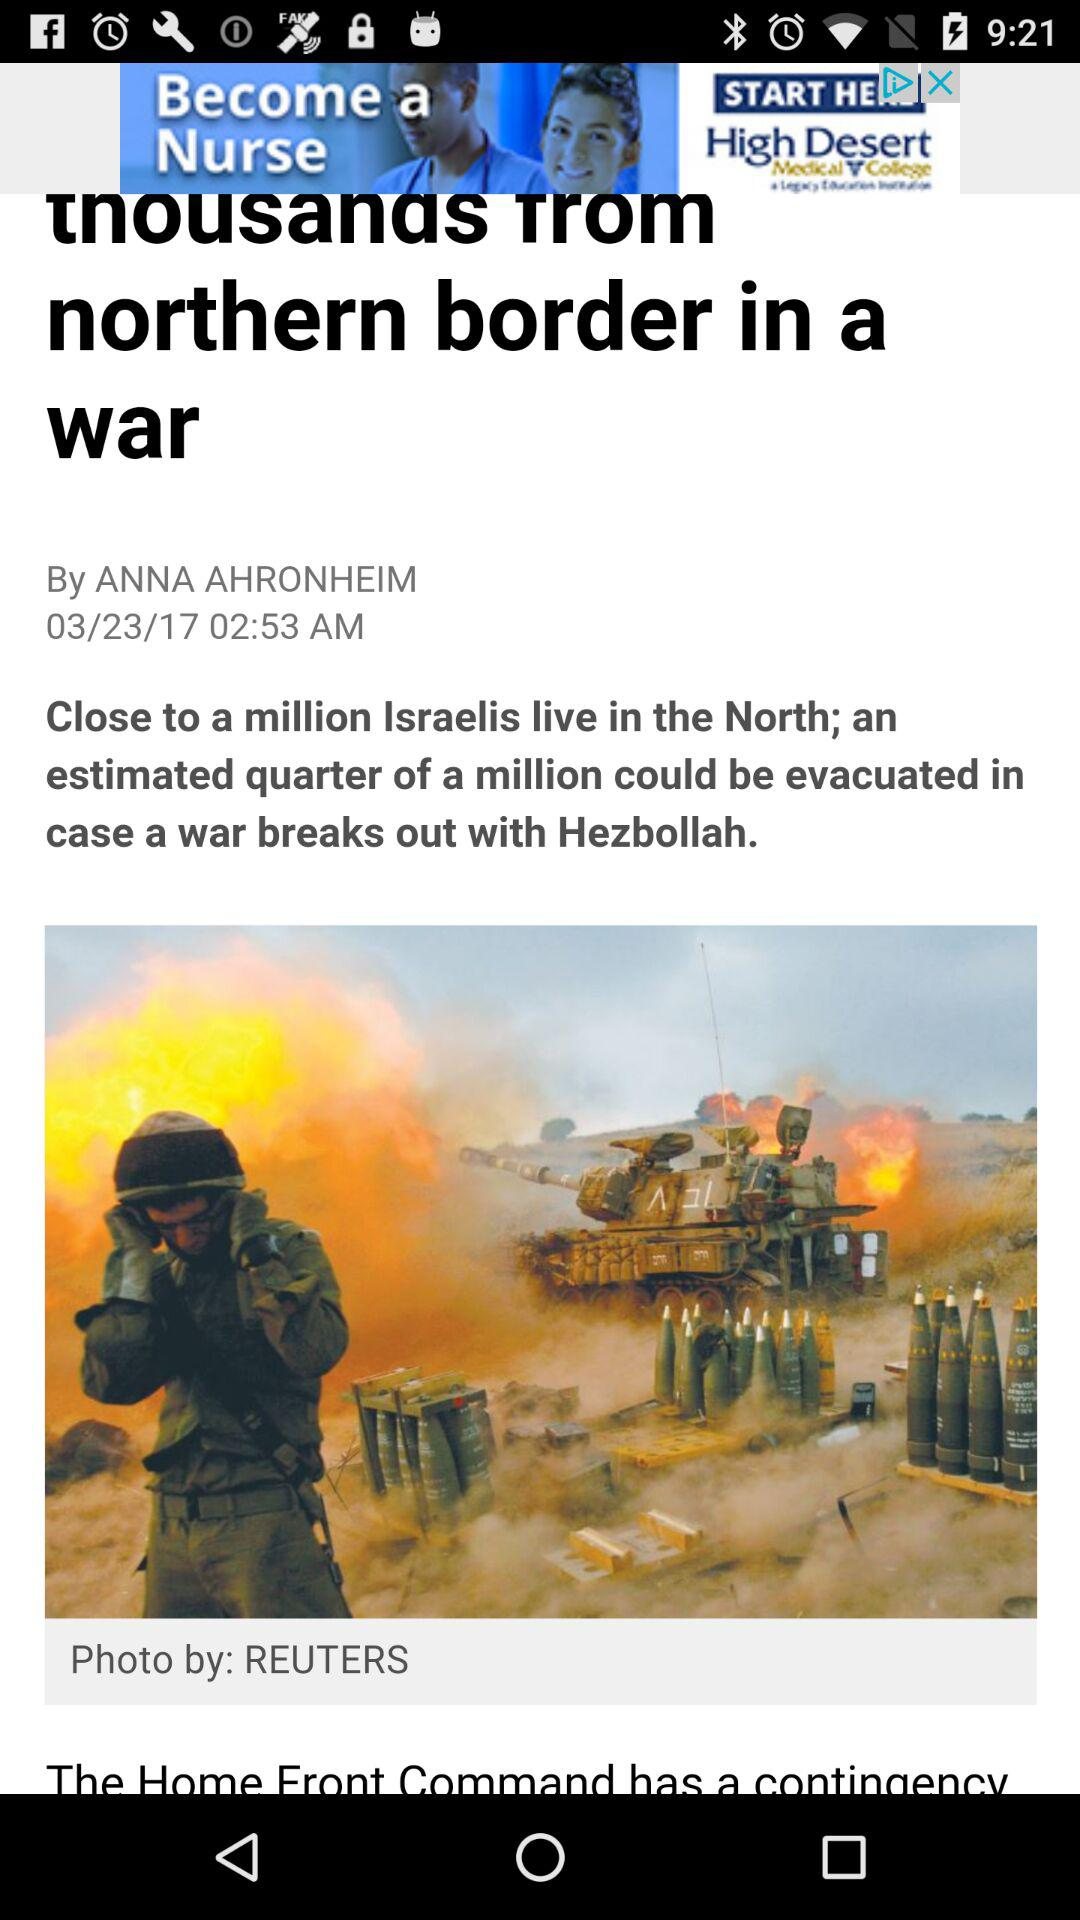Who wrote the article? The article was written by Anna Ahronheim. 